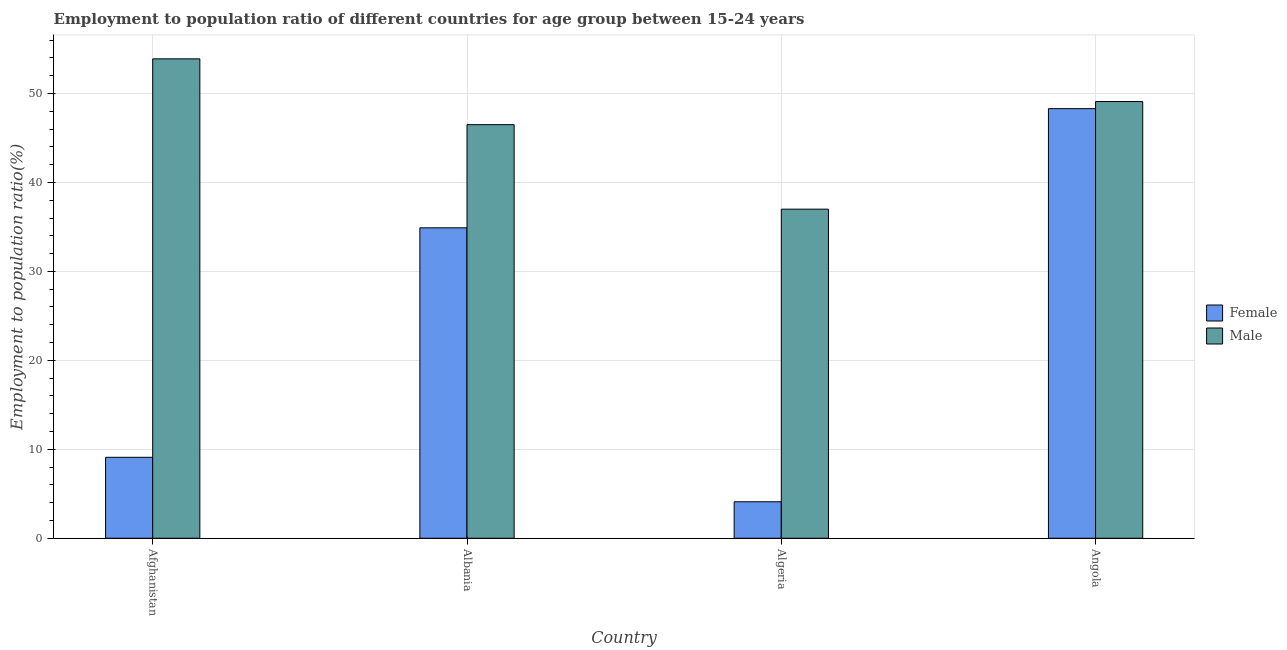How many different coloured bars are there?
Give a very brief answer. 2. How many groups of bars are there?
Your answer should be very brief. 4. Are the number of bars per tick equal to the number of legend labels?
Give a very brief answer. Yes. Are the number of bars on each tick of the X-axis equal?
Make the answer very short. Yes. How many bars are there on the 3rd tick from the left?
Provide a succinct answer. 2. How many bars are there on the 2nd tick from the right?
Keep it short and to the point. 2. What is the label of the 1st group of bars from the left?
Ensure brevity in your answer.  Afghanistan. What is the employment to population ratio(male) in Albania?
Ensure brevity in your answer.  46.5. Across all countries, what is the maximum employment to population ratio(male)?
Offer a terse response. 53.9. Across all countries, what is the minimum employment to population ratio(male)?
Offer a very short reply. 37. In which country was the employment to population ratio(female) maximum?
Offer a very short reply. Angola. In which country was the employment to population ratio(female) minimum?
Provide a succinct answer. Algeria. What is the total employment to population ratio(female) in the graph?
Provide a succinct answer. 96.4. What is the difference between the employment to population ratio(female) in Albania and that in Angola?
Keep it short and to the point. -13.4. What is the difference between the employment to population ratio(female) in Afghanistan and the employment to population ratio(male) in Albania?
Offer a terse response. -37.4. What is the average employment to population ratio(male) per country?
Your response must be concise. 46.62. What is the difference between the employment to population ratio(male) and employment to population ratio(female) in Angola?
Your answer should be compact. 0.8. In how many countries, is the employment to population ratio(male) greater than 32 %?
Offer a terse response. 4. What is the ratio of the employment to population ratio(male) in Afghanistan to that in Albania?
Your answer should be compact. 1.16. Is the difference between the employment to population ratio(male) in Albania and Algeria greater than the difference between the employment to population ratio(female) in Albania and Algeria?
Provide a short and direct response. No. What is the difference between the highest and the second highest employment to population ratio(male)?
Make the answer very short. 4.8. What is the difference between the highest and the lowest employment to population ratio(male)?
Your response must be concise. 16.9. Is the sum of the employment to population ratio(female) in Afghanistan and Algeria greater than the maximum employment to population ratio(male) across all countries?
Offer a very short reply. No. What does the 1st bar from the left in Afghanistan represents?
Give a very brief answer. Female. What does the 2nd bar from the right in Angola represents?
Your answer should be compact. Female. What is the difference between two consecutive major ticks on the Y-axis?
Make the answer very short. 10. Does the graph contain grids?
Your answer should be compact. Yes. How many legend labels are there?
Make the answer very short. 2. What is the title of the graph?
Ensure brevity in your answer.  Employment to population ratio of different countries for age group between 15-24 years. What is the Employment to population ratio(%) in Female in Afghanistan?
Provide a short and direct response. 9.1. What is the Employment to population ratio(%) of Male in Afghanistan?
Provide a short and direct response. 53.9. What is the Employment to population ratio(%) in Female in Albania?
Make the answer very short. 34.9. What is the Employment to population ratio(%) of Male in Albania?
Make the answer very short. 46.5. What is the Employment to population ratio(%) in Female in Algeria?
Give a very brief answer. 4.1. What is the Employment to population ratio(%) of Female in Angola?
Your answer should be compact. 48.3. What is the Employment to population ratio(%) of Male in Angola?
Your response must be concise. 49.1. Across all countries, what is the maximum Employment to population ratio(%) in Female?
Ensure brevity in your answer.  48.3. Across all countries, what is the maximum Employment to population ratio(%) of Male?
Make the answer very short. 53.9. Across all countries, what is the minimum Employment to population ratio(%) of Female?
Ensure brevity in your answer.  4.1. What is the total Employment to population ratio(%) of Female in the graph?
Provide a succinct answer. 96.4. What is the total Employment to population ratio(%) of Male in the graph?
Offer a very short reply. 186.5. What is the difference between the Employment to population ratio(%) of Female in Afghanistan and that in Albania?
Offer a terse response. -25.8. What is the difference between the Employment to population ratio(%) in Male in Afghanistan and that in Albania?
Ensure brevity in your answer.  7.4. What is the difference between the Employment to population ratio(%) of Female in Afghanistan and that in Algeria?
Offer a very short reply. 5. What is the difference between the Employment to population ratio(%) in Female in Afghanistan and that in Angola?
Provide a short and direct response. -39.2. What is the difference between the Employment to population ratio(%) of Male in Afghanistan and that in Angola?
Offer a very short reply. 4.8. What is the difference between the Employment to population ratio(%) of Female in Albania and that in Algeria?
Your answer should be compact. 30.8. What is the difference between the Employment to population ratio(%) of Male in Albania and that in Angola?
Your answer should be very brief. -2.6. What is the difference between the Employment to population ratio(%) in Female in Algeria and that in Angola?
Provide a succinct answer. -44.2. What is the difference between the Employment to population ratio(%) in Female in Afghanistan and the Employment to population ratio(%) in Male in Albania?
Offer a very short reply. -37.4. What is the difference between the Employment to population ratio(%) of Female in Afghanistan and the Employment to population ratio(%) of Male in Algeria?
Your response must be concise. -27.9. What is the difference between the Employment to population ratio(%) of Female in Afghanistan and the Employment to population ratio(%) of Male in Angola?
Give a very brief answer. -40. What is the difference between the Employment to population ratio(%) of Female in Albania and the Employment to population ratio(%) of Male in Algeria?
Your answer should be compact. -2.1. What is the difference between the Employment to population ratio(%) in Female in Algeria and the Employment to population ratio(%) in Male in Angola?
Your response must be concise. -45. What is the average Employment to population ratio(%) of Female per country?
Your answer should be very brief. 24.1. What is the average Employment to population ratio(%) in Male per country?
Ensure brevity in your answer.  46.62. What is the difference between the Employment to population ratio(%) in Female and Employment to population ratio(%) in Male in Afghanistan?
Your response must be concise. -44.8. What is the difference between the Employment to population ratio(%) in Female and Employment to population ratio(%) in Male in Albania?
Offer a very short reply. -11.6. What is the difference between the Employment to population ratio(%) of Female and Employment to population ratio(%) of Male in Algeria?
Ensure brevity in your answer.  -32.9. What is the ratio of the Employment to population ratio(%) in Female in Afghanistan to that in Albania?
Provide a short and direct response. 0.26. What is the ratio of the Employment to population ratio(%) in Male in Afghanistan to that in Albania?
Ensure brevity in your answer.  1.16. What is the ratio of the Employment to population ratio(%) in Female in Afghanistan to that in Algeria?
Your answer should be very brief. 2.22. What is the ratio of the Employment to population ratio(%) in Male in Afghanistan to that in Algeria?
Keep it short and to the point. 1.46. What is the ratio of the Employment to population ratio(%) in Female in Afghanistan to that in Angola?
Your answer should be compact. 0.19. What is the ratio of the Employment to population ratio(%) of Male in Afghanistan to that in Angola?
Keep it short and to the point. 1.1. What is the ratio of the Employment to population ratio(%) in Female in Albania to that in Algeria?
Your answer should be very brief. 8.51. What is the ratio of the Employment to population ratio(%) in Male in Albania to that in Algeria?
Offer a terse response. 1.26. What is the ratio of the Employment to population ratio(%) in Female in Albania to that in Angola?
Ensure brevity in your answer.  0.72. What is the ratio of the Employment to population ratio(%) of Male in Albania to that in Angola?
Provide a short and direct response. 0.95. What is the ratio of the Employment to population ratio(%) of Female in Algeria to that in Angola?
Make the answer very short. 0.08. What is the ratio of the Employment to population ratio(%) of Male in Algeria to that in Angola?
Provide a short and direct response. 0.75. What is the difference between the highest and the second highest Employment to population ratio(%) in Female?
Your answer should be compact. 13.4. What is the difference between the highest and the lowest Employment to population ratio(%) of Female?
Keep it short and to the point. 44.2. What is the difference between the highest and the lowest Employment to population ratio(%) in Male?
Your answer should be very brief. 16.9. 